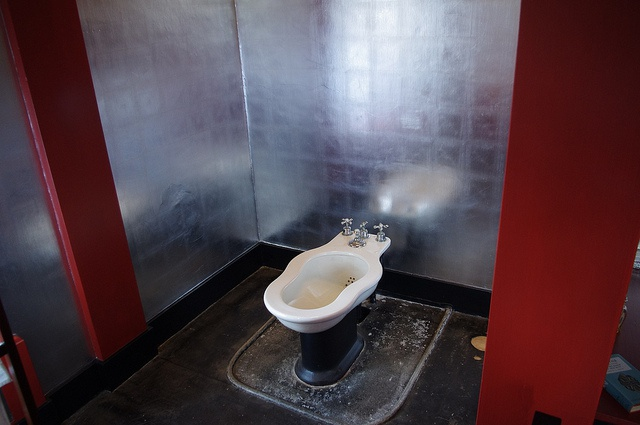Describe the objects in this image and their specific colors. I can see toilet in black, darkgray, lightgray, and gray tones and book in black, gray, and maroon tones in this image. 